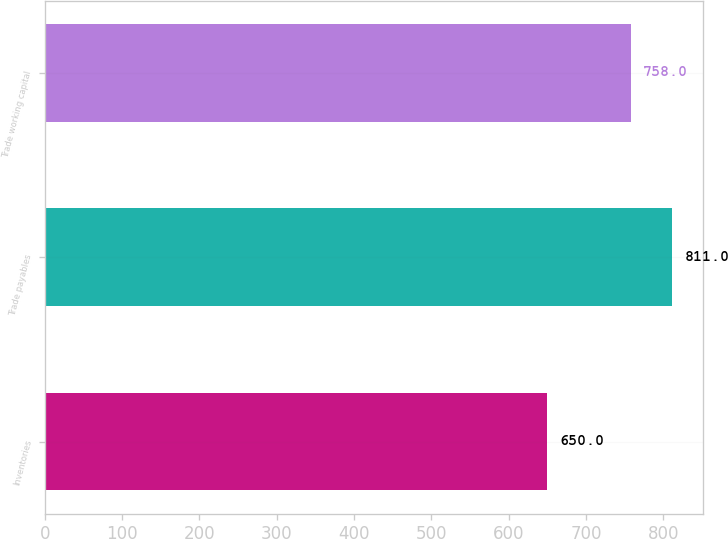Convert chart to OTSL. <chart><loc_0><loc_0><loc_500><loc_500><bar_chart><fcel>Inventories<fcel>Trade payables<fcel>Trade working capital<nl><fcel>650<fcel>811<fcel>758<nl></chart> 